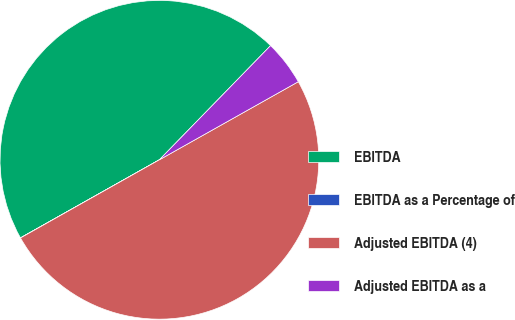Convert chart. <chart><loc_0><loc_0><loc_500><loc_500><pie_chart><fcel>EBITDA<fcel>EBITDA as a Percentage of<fcel>Adjusted EBITDA (4)<fcel>Adjusted EBITDA as a<nl><fcel>45.44%<fcel>0.01%<fcel>49.99%<fcel>4.56%<nl></chart> 